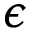<formula> <loc_0><loc_0><loc_500><loc_500>\epsilon</formula> 